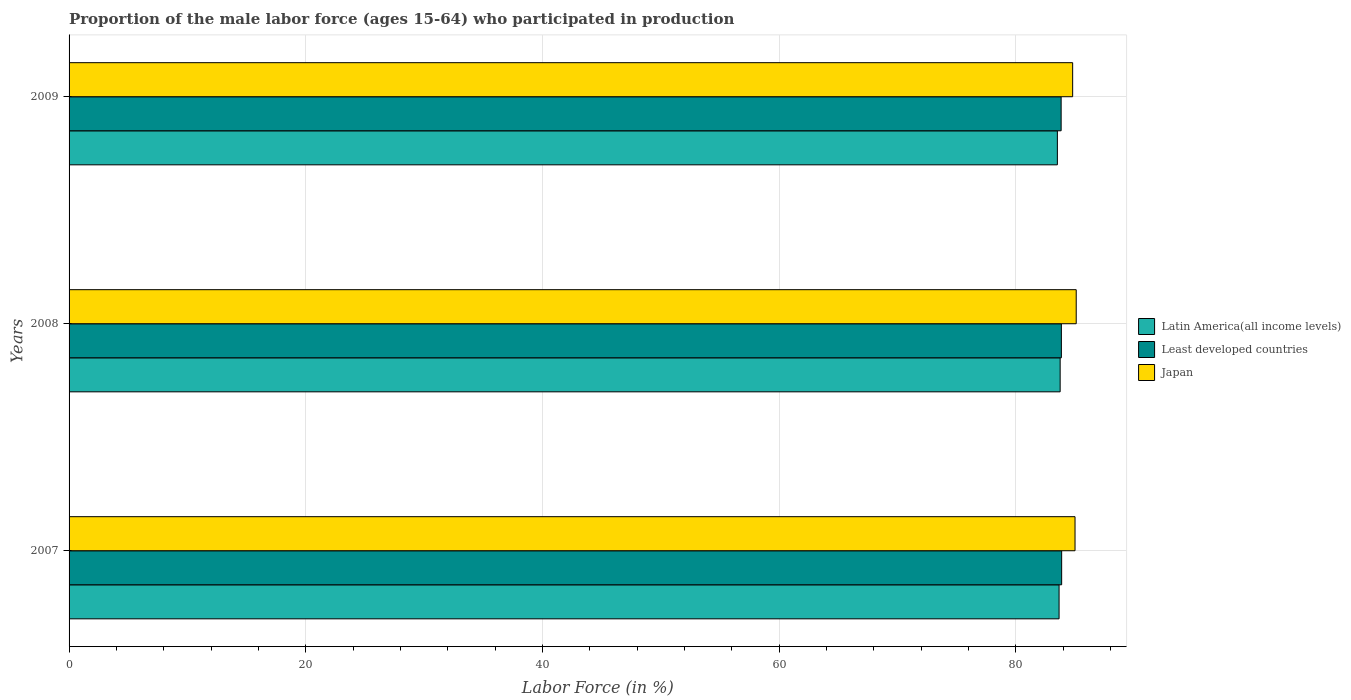How many groups of bars are there?
Your answer should be compact. 3. Are the number of bars on each tick of the Y-axis equal?
Ensure brevity in your answer.  Yes. In how many cases, is the number of bars for a given year not equal to the number of legend labels?
Ensure brevity in your answer.  0. What is the proportion of the male labor force who participated in production in Latin America(all income levels) in 2009?
Your answer should be compact. 83.51. Across all years, what is the maximum proportion of the male labor force who participated in production in Japan?
Offer a terse response. 85.1. Across all years, what is the minimum proportion of the male labor force who participated in production in Least developed countries?
Ensure brevity in your answer.  83.83. What is the total proportion of the male labor force who participated in production in Latin America(all income levels) in the graph?
Give a very brief answer. 250.9. What is the difference between the proportion of the male labor force who participated in production in Latin America(all income levels) in 2008 and that in 2009?
Keep it short and to the point. 0.23. What is the difference between the proportion of the male labor force who participated in production in Least developed countries in 2009 and the proportion of the male labor force who participated in production in Latin America(all income levels) in 2008?
Offer a very short reply. 0.08. What is the average proportion of the male labor force who participated in production in Latin America(all income levels) per year?
Provide a succinct answer. 83.63. In the year 2007, what is the difference between the proportion of the male labor force who participated in production in Japan and proportion of the male labor force who participated in production in Latin America(all income levels)?
Keep it short and to the point. 1.35. In how many years, is the proportion of the male labor force who participated in production in Least developed countries greater than 72 %?
Your response must be concise. 3. What is the ratio of the proportion of the male labor force who participated in production in Least developed countries in 2007 to that in 2008?
Keep it short and to the point. 1. Is the proportion of the male labor force who participated in production in Japan in 2007 less than that in 2008?
Offer a very short reply. Yes. What is the difference between the highest and the second highest proportion of the male labor force who participated in production in Japan?
Offer a terse response. 0.1. What is the difference between the highest and the lowest proportion of the male labor force who participated in production in Least developed countries?
Your response must be concise. 0.04. What does the 1st bar from the top in 2009 represents?
Make the answer very short. Japan. What does the 2nd bar from the bottom in 2007 represents?
Your answer should be very brief. Least developed countries. Are all the bars in the graph horizontal?
Provide a short and direct response. Yes. How many years are there in the graph?
Keep it short and to the point. 3. What is the difference between two consecutive major ticks on the X-axis?
Ensure brevity in your answer.  20. Are the values on the major ticks of X-axis written in scientific E-notation?
Your answer should be very brief. No. Does the graph contain any zero values?
Ensure brevity in your answer.  No. Where does the legend appear in the graph?
Your answer should be compact. Center right. How are the legend labels stacked?
Your response must be concise. Vertical. What is the title of the graph?
Give a very brief answer. Proportion of the male labor force (ages 15-64) who participated in production. What is the label or title of the Y-axis?
Provide a short and direct response. Years. What is the Labor Force (in %) of Latin America(all income levels) in 2007?
Make the answer very short. 83.65. What is the Labor Force (in %) in Least developed countries in 2007?
Provide a short and direct response. 83.87. What is the Labor Force (in %) in Latin America(all income levels) in 2008?
Ensure brevity in your answer.  83.74. What is the Labor Force (in %) of Least developed countries in 2008?
Your answer should be compact. 83.85. What is the Labor Force (in %) of Japan in 2008?
Ensure brevity in your answer.  85.1. What is the Labor Force (in %) of Latin America(all income levels) in 2009?
Keep it short and to the point. 83.51. What is the Labor Force (in %) in Least developed countries in 2009?
Provide a succinct answer. 83.83. What is the Labor Force (in %) in Japan in 2009?
Your response must be concise. 84.8. Across all years, what is the maximum Labor Force (in %) in Latin America(all income levels)?
Give a very brief answer. 83.74. Across all years, what is the maximum Labor Force (in %) in Least developed countries?
Your response must be concise. 83.87. Across all years, what is the maximum Labor Force (in %) in Japan?
Provide a short and direct response. 85.1. Across all years, what is the minimum Labor Force (in %) of Latin America(all income levels)?
Your answer should be compact. 83.51. Across all years, what is the minimum Labor Force (in %) in Least developed countries?
Keep it short and to the point. 83.83. Across all years, what is the minimum Labor Force (in %) in Japan?
Offer a terse response. 84.8. What is the total Labor Force (in %) in Latin America(all income levels) in the graph?
Give a very brief answer. 250.9. What is the total Labor Force (in %) in Least developed countries in the graph?
Make the answer very short. 251.54. What is the total Labor Force (in %) of Japan in the graph?
Ensure brevity in your answer.  254.9. What is the difference between the Labor Force (in %) in Latin America(all income levels) in 2007 and that in 2008?
Offer a very short reply. -0.09. What is the difference between the Labor Force (in %) in Least developed countries in 2007 and that in 2008?
Your answer should be compact. 0.02. What is the difference between the Labor Force (in %) in Japan in 2007 and that in 2008?
Offer a very short reply. -0.1. What is the difference between the Labor Force (in %) in Latin America(all income levels) in 2007 and that in 2009?
Your answer should be very brief. 0.14. What is the difference between the Labor Force (in %) of Least developed countries in 2007 and that in 2009?
Your answer should be very brief. 0.04. What is the difference between the Labor Force (in %) of Japan in 2007 and that in 2009?
Offer a very short reply. 0.2. What is the difference between the Labor Force (in %) in Latin America(all income levels) in 2008 and that in 2009?
Keep it short and to the point. 0.23. What is the difference between the Labor Force (in %) of Least developed countries in 2008 and that in 2009?
Keep it short and to the point. 0.02. What is the difference between the Labor Force (in %) of Japan in 2008 and that in 2009?
Your response must be concise. 0.3. What is the difference between the Labor Force (in %) in Latin America(all income levels) in 2007 and the Labor Force (in %) in Least developed countries in 2008?
Your response must be concise. -0.19. What is the difference between the Labor Force (in %) in Latin America(all income levels) in 2007 and the Labor Force (in %) in Japan in 2008?
Your answer should be compact. -1.45. What is the difference between the Labor Force (in %) of Least developed countries in 2007 and the Labor Force (in %) of Japan in 2008?
Make the answer very short. -1.23. What is the difference between the Labor Force (in %) of Latin America(all income levels) in 2007 and the Labor Force (in %) of Least developed countries in 2009?
Your response must be concise. -0.17. What is the difference between the Labor Force (in %) of Latin America(all income levels) in 2007 and the Labor Force (in %) of Japan in 2009?
Make the answer very short. -1.15. What is the difference between the Labor Force (in %) in Least developed countries in 2007 and the Labor Force (in %) in Japan in 2009?
Keep it short and to the point. -0.93. What is the difference between the Labor Force (in %) of Latin America(all income levels) in 2008 and the Labor Force (in %) of Least developed countries in 2009?
Make the answer very short. -0.08. What is the difference between the Labor Force (in %) in Latin America(all income levels) in 2008 and the Labor Force (in %) in Japan in 2009?
Your answer should be compact. -1.06. What is the difference between the Labor Force (in %) in Least developed countries in 2008 and the Labor Force (in %) in Japan in 2009?
Offer a terse response. -0.95. What is the average Labor Force (in %) of Latin America(all income levels) per year?
Ensure brevity in your answer.  83.63. What is the average Labor Force (in %) in Least developed countries per year?
Keep it short and to the point. 83.85. What is the average Labor Force (in %) in Japan per year?
Your response must be concise. 84.97. In the year 2007, what is the difference between the Labor Force (in %) of Latin America(all income levels) and Labor Force (in %) of Least developed countries?
Offer a terse response. -0.22. In the year 2007, what is the difference between the Labor Force (in %) in Latin America(all income levels) and Labor Force (in %) in Japan?
Ensure brevity in your answer.  -1.35. In the year 2007, what is the difference between the Labor Force (in %) in Least developed countries and Labor Force (in %) in Japan?
Provide a short and direct response. -1.13. In the year 2008, what is the difference between the Labor Force (in %) of Latin America(all income levels) and Labor Force (in %) of Least developed countries?
Offer a terse response. -0.1. In the year 2008, what is the difference between the Labor Force (in %) in Latin America(all income levels) and Labor Force (in %) in Japan?
Make the answer very short. -1.36. In the year 2008, what is the difference between the Labor Force (in %) in Least developed countries and Labor Force (in %) in Japan?
Offer a terse response. -1.25. In the year 2009, what is the difference between the Labor Force (in %) in Latin America(all income levels) and Labor Force (in %) in Least developed countries?
Provide a short and direct response. -0.32. In the year 2009, what is the difference between the Labor Force (in %) in Latin America(all income levels) and Labor Force (in %) in Japan?
Provide a short and direct response. -1.29. In the year 2009, what is the difference between the Labor Force (in %) of Least developed countries and Labor Force (in %) of Japan?
Your answer should be compact. -0.97. What is the ratio of the Labor Force (in %) in Japan in 2007 to that in 2008?
Offer a very short reply. 1. What is the ratio of the Labor Force (in %) of Latin America(all income levels) in 2007 to that in 2009?
Provide a short and direct response. 1. What is the ratio of the Labor Force (in %) of Japan in 2007 to that in 2009?
Provide a succinct answer. 1. What is the ratio of the Labor Force (in %) of Latin America(all income levels) in 2008 to that in 2009?
Give a very brief answer. 1. What is the ratio of the Labor Force (in %) in Least developed countries in 2008 to that in 2009?
Make the answer very short. 1. What is the ratio of the Labor Force (in %) of Japan in 2008 to that in 2009?
Your response must be concise. 1. What is the difference between the highest and the second highest Labor Force (in %) in Latin America(all income levels)?
Your answer should be compact. 0.09. What is the difference between the highest and the second highest Labor Force (in %) of Least developed countries?
Provide a succinct answer. 0.02. What is the difference between the highest and the lowest Labor Force (in %) in Latin America(all income levels)?
Make the answer very short. 0.23. What is the difference between the highest and the lowest Labor Force (in %) of Least developed countries?
Your answer should be compact. 0.04. 